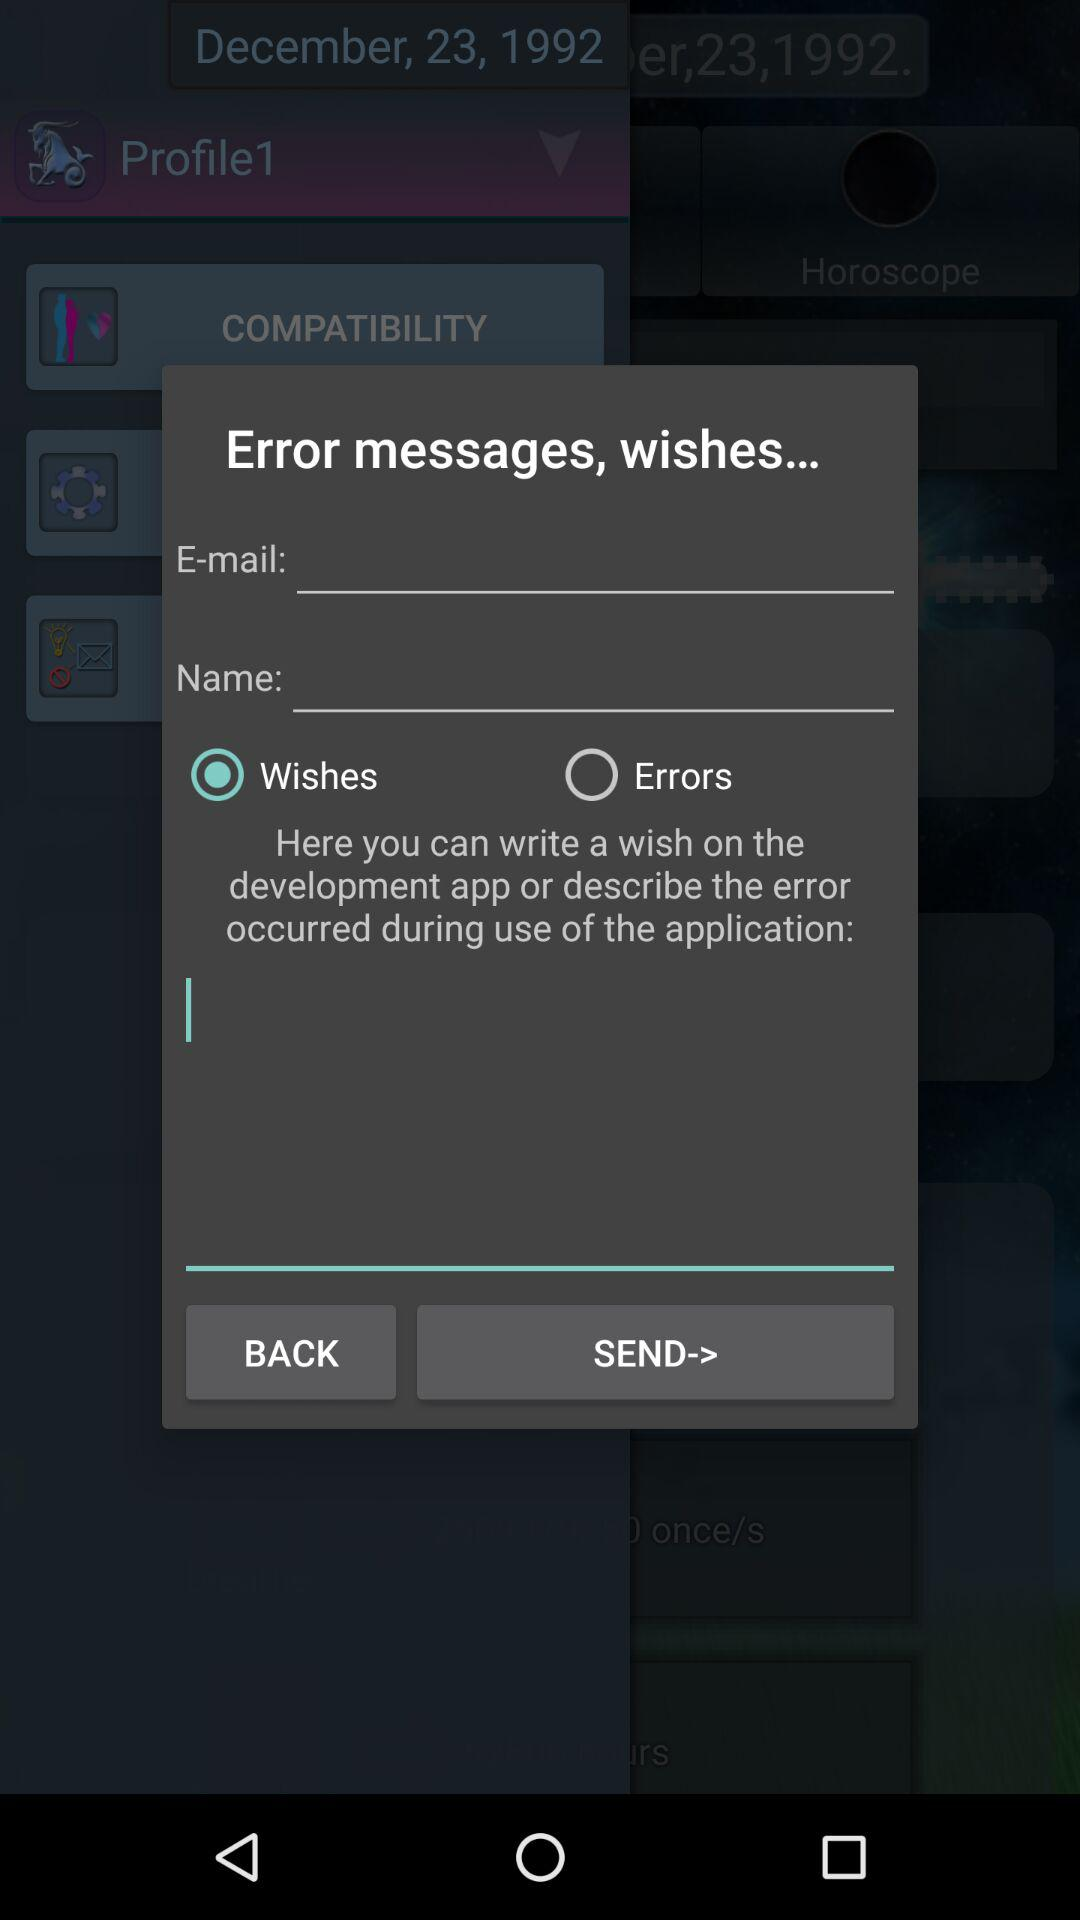What option is selected? The selected option is "Wishes". 